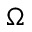<formula> <loc_0><loc_0><loc_500><loc_500>\Omega</formula> 